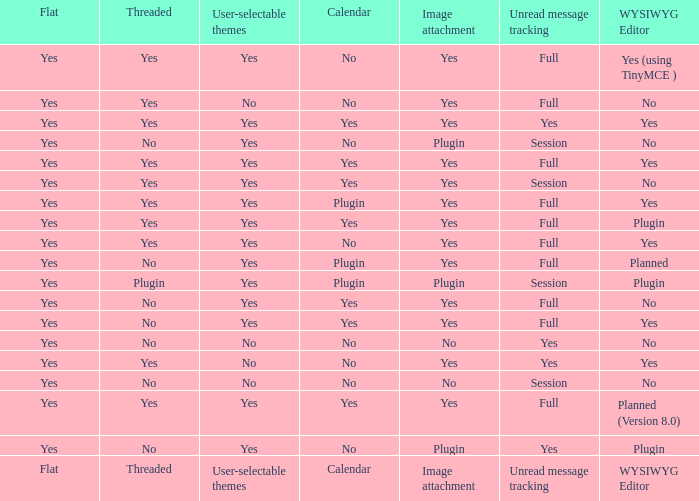Which calendar possesses a wysiwyg editor of none, and an unread message monitoring of session, and an image attachment of none? No. Help me parse the entirety of this table. {'header': ['Flat', 'Threaded', 'User-selectable themes', 'Calendar', 'Image attachment', 'Unread message tracking', 'WYSIWYG Editor'], 'rows': [['Yes', 'Yes', 'Yes', 'No', 'Yes', 'Full', 'Yes (using TinyMCE )'], ['Yes', 'Yes', 'No', 'No', 'Yes', 'Full', 'No'], ['Yes', 'Yes', 'Yes', 'Yes', 'Yes', 'Yes', 'Yes'], ['Yes', 'No', 'Yes', 'No', 'Plugin', 'Session', 'No'], ['Yes', 'Yes', 'Yes', 'Yes', 'Yes', 'Full', 'Yes'], ['Yes', 'Yes', 'Yes', 'Yes', 'Yes', 'Session', 'No'], ['Yes', 'Yes', 'Yes', 'Plugin', 'Yes', 'Full', 'Yes'], ['Yes', 'Yes', 'Yes', 'Yes', 'Yes', 'Full', 'Plugin'], ['Yes', 'Yes', 'Yes', 'No', 'Yes', 'Full', 'Yes'], ['Yes', 'No', 'Yes', 'Plugin', 'Yes', 'Full', 'Planned'], ['Yes', 'Plugin', 'Yes', 'Plugin', 'Plugin', 'Session', 'Plugin'], ['Yes', 'No', 'Yes', 'Yes', 'Yes', 'Full', 'No'], ['Yes', 'No', 'Yes', 'Yes', 'Yes', 'Full', 'Yes'], ['Yes', 'No', 'No', 'No', 'No', 'Yes', 'No'], ['Yes', 'Yes', 'No', 'No', 'Yes', 'Yes', 'Yes'], ['Yes', 'No', 'No', 'No', 'No', 'Session', 'No'], ['Yes', 'Yes', 'Yes', 'Yes', 'Yes', 'Full', 'Planned (Version 8.0)'], ['Yes', 'No', 'Yes', 'No', 'Plugin', 'Yes', 'Plugin'], ['Flat', 'Threaded', 'User-selectable themes', 'Calendar', 'Image attachment', 'Unread message tracking', 'WYSIWYG Editor']]} 